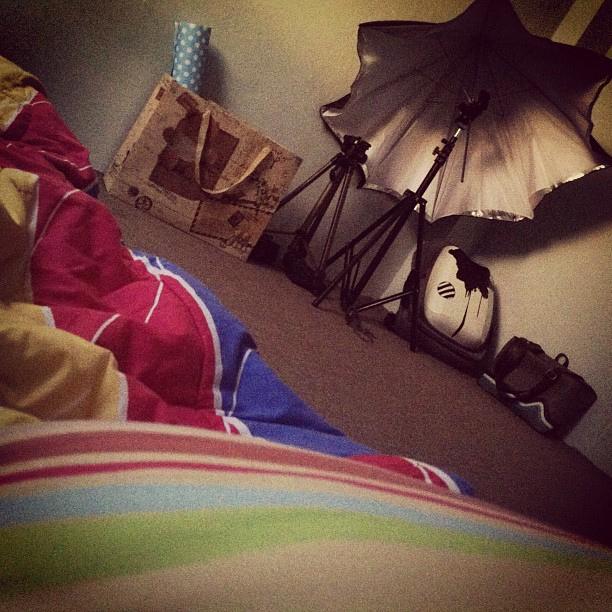What are these items used for?
Concise answer only. Photography. How many objects are shown in the picture?
Concise answer only. 6. Is the blanket colorful?
Quick response, please. Yes. 